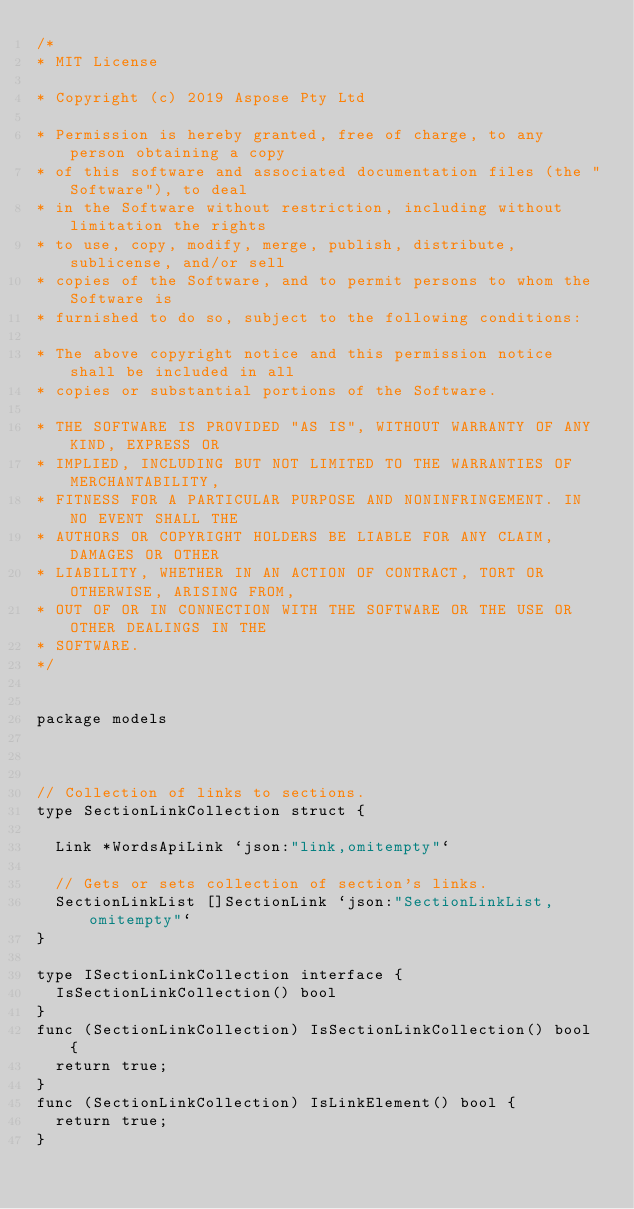<code> <loc_0><loc_0><loc_500><loc_500><_Go_>/*
* MIT License

* Copyright (c) 2019 Aspose Pty Ltd

* Permission is hereby granted, free of charge, to any person obtaining a copy
* of this software and associated documentation files (the "Software"), to deal
* in the Software without restriction, including without limitation the rights
* to use, copy, modify, merge, publish, distribute, sublicense, and/or sell
* copies of the Software, and to permit persons to whom the Software is
* furnished to do so, subject to the following conditions:

* The above copyright notice and this permission notice shall be included in all
* copies or substantial portions of the Software.

* THE SOFTWARE IS PROVIDED "AS IS", WITHOUT WARRANTY OF ANY KIND, EXPRESS OR
* IMPLIED, INCLUDING BUT NOT LIMITED TO THE WARRANTIES OF MERCHANTABILITY,
* FITNESS FOR A PARTICULAR PURPOSE AND NONINFRINGEMENT. IN NO EVENT SHALL THE
* AUTHORS OR COPYRIGHT HOLDERS BE LIABLE FOR ANY CLAIM, DAMAGES OR OTHER
* LIABILITY, WHETHER IN AN ACTION OF CONTRACT, TORT OR OTHERWISE, ARISING FROM,
* OUT OF OR IN CONNECTION WITH THE SOFTWARE OR THE USE OR OTHER DEALINGS IN THE
* SOFTWARE.
*/


package models



// Collection of links to sections.
type SectionLinkCollection struct {

	Link *WordsApiLink `json:"link,omitempty"`

	// Gets or sets collection of section's links.
	SectionLinkList []SectionLink `json:"SectionLinkList,omitempty"`
}

type ISectionLinkCollection interface {
	IsSectionLinkCollection() bool
}
func (SectionLinkCollection) IsSectionLinkCollection() bool {
	return true;
}
func (SectionLinkCollection) IsLinkElement() bool {
	return true;
}
</code> 